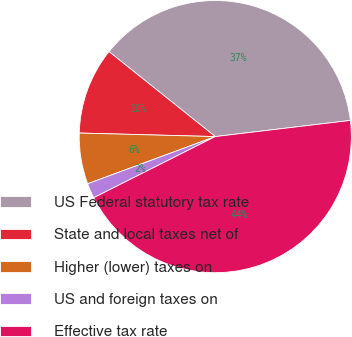Convert chart to OTSL. <chart><loc_0><loc_0><loc_500><loc_500><pie_chart><fcel>US Federal statutory tax rate<fcel>State and local taxes net of<fcel>Higher (lower) taxes on<fcel>US and foreign taxes on<fcel>Effective tax rate<nl><fcel>37.37%<fcel>10.32%<fcel>6.05%<fcel>1.78%<fcel>44.48%<nl></chart> 